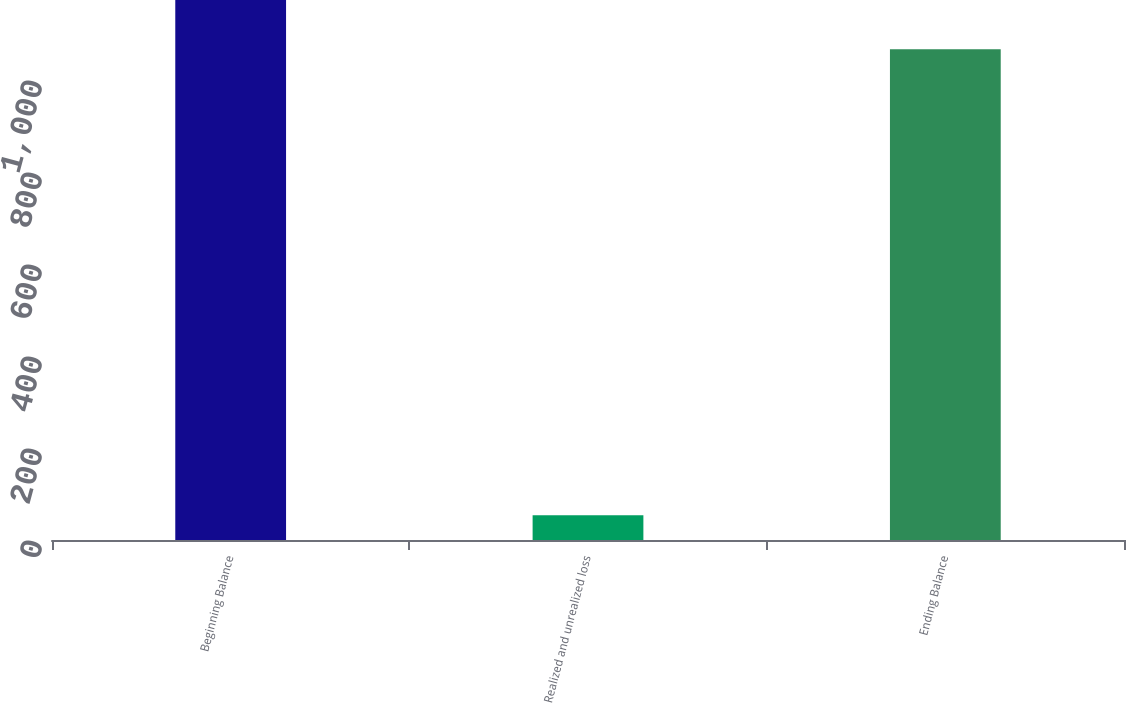Convert chart to OTSL. <chart><loc_0><loc_0><loc_500><loc_500><bar_chart><fcel>Beginning Balance<fcel>Realized and unrealized loss<fcel>Ending Balance<nl><fcel>1173.7<fcel>54<fcel>1067<nl></chart> 